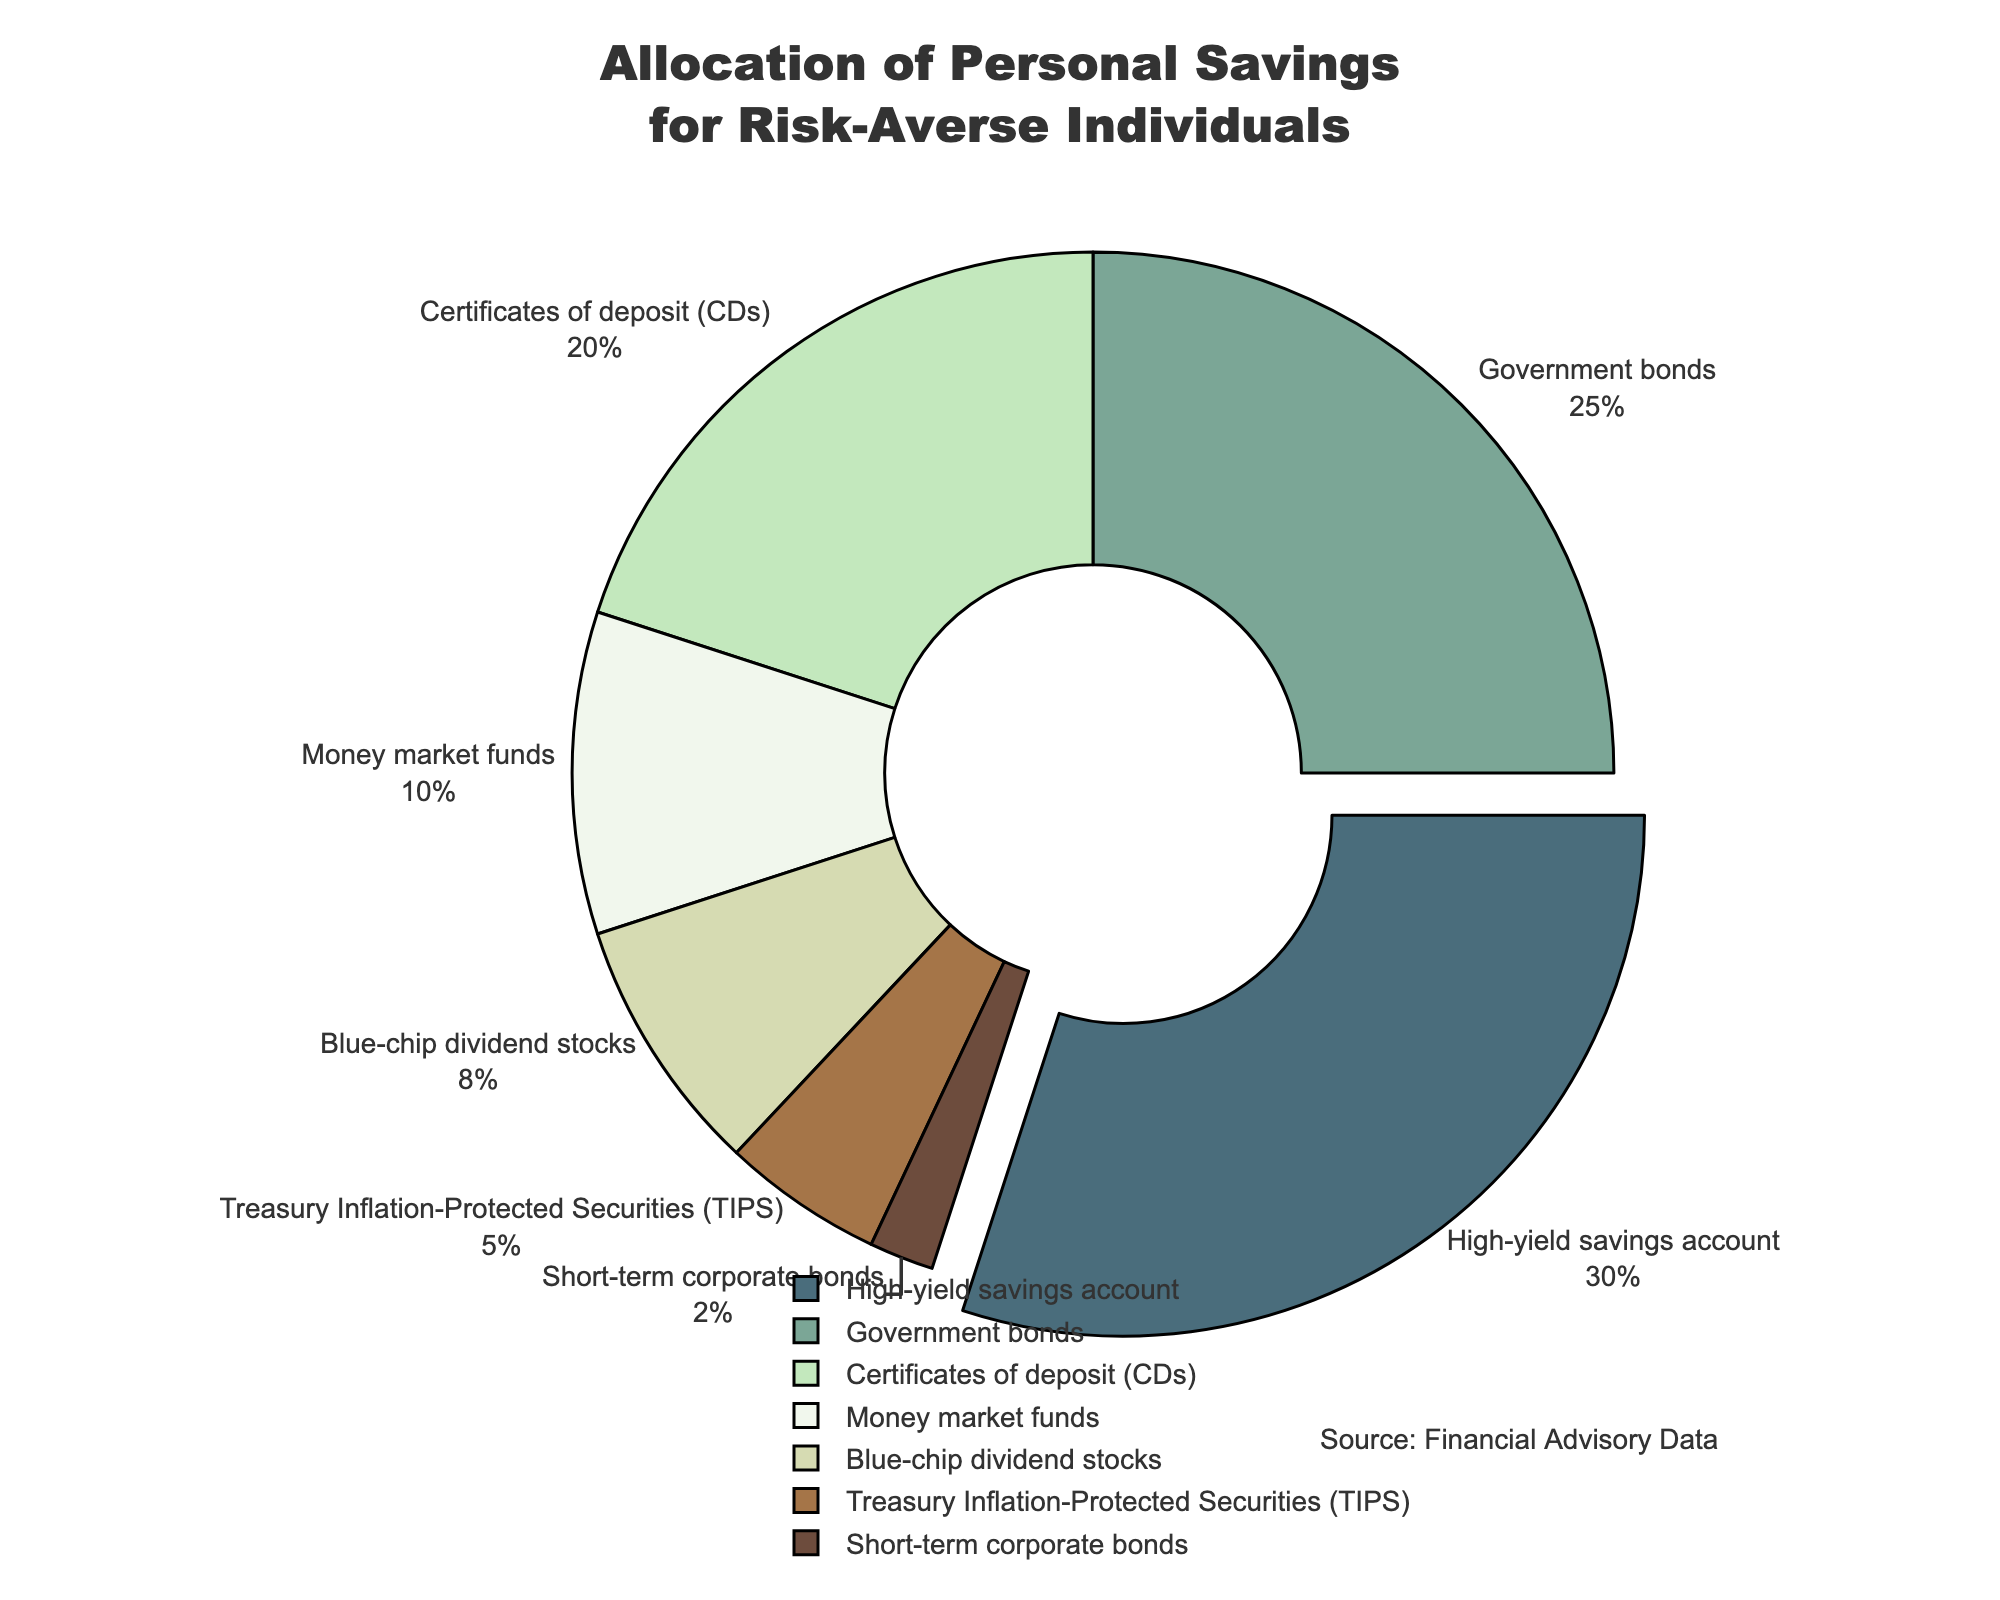Which investment vehicle has the highest allocation? The pie chart shows the percentages of personal savings allocated to different investment vehicles. The segment with the largest percentage represents the highest allocation.
Answer: High-yield savings account What is the combined percentage allocation for government bonds and CDs? To find the combined allocation, add the percentages for government bonds (25%) and CDs (20%). The result is 25 + 20 = 45.
Answer: 45% Is the allocation for blue-chip dividend stocks higher or lower than money market funds? By comparing the percentages for blue-chip dividend stocks (8%) and money market funds (10%), we see that 8% is less than 10%.
Answer: Lower What is the total percentage allocated to the three least represented investment vehicles? The three least represented vehicles are Treasury Inflation-Protected Securities (TIPS) (5%), short-term corporate bonds (2%), and blue-chip dividend stocks (8%). Summing these gives 5 + 2 + 8 = 15.
Answer: 15% Which segment is "pulled out" in the pie chart, and why? The segment pulled out is the one with the highest percentage, as indicated in the chart design. The highest allocated investment vehicle is the high-yield savings account, with 30%.
Answer: High-yield savings account What is the difference in percentage between the highest and lowest allocated investment vehicles? Subtract the percentage of the lowest allocated investment vehicle (short-term corporate bonds at 2%) from the highest allocated one (high-yield savings account at 30%). The difference is 30 - 2 = 28.
Answer: 28% Are the combined allocations for TIPS and short-term corporate bonds higher or lower than that for government bonds? Combined, TIPS (5%) and short-term corporate bonds (2%) total 7%. Comparing with government bonds (25%), 7% is less than 25%.
Answer: Lower What percentage of the total allocation is represented by less than 10% allocations? The percentages less than 10% are money market funds (10%), blue-chip dividend stocks (8%), TIPS (5%), and short-term corporate bonds (2%). Summing these gives 10 + 8 + 5 + 2 = 25.
Answer: 25% What color represents the allocation for certificates of deposit (CDs)? To identify the color, refer to the segment labeled certificates of deposit (CDs) in the chart. The palette used includes unique colors for each segment.
Answer: Green Does any single investment vehicle allocate more than 50% of personal savings? By reviewing the percentages of all segments, none of them allocates more than 30%, which is the highest allocation. Therefore, no single investment vehicle allocates more than 50%.
Answer: No 